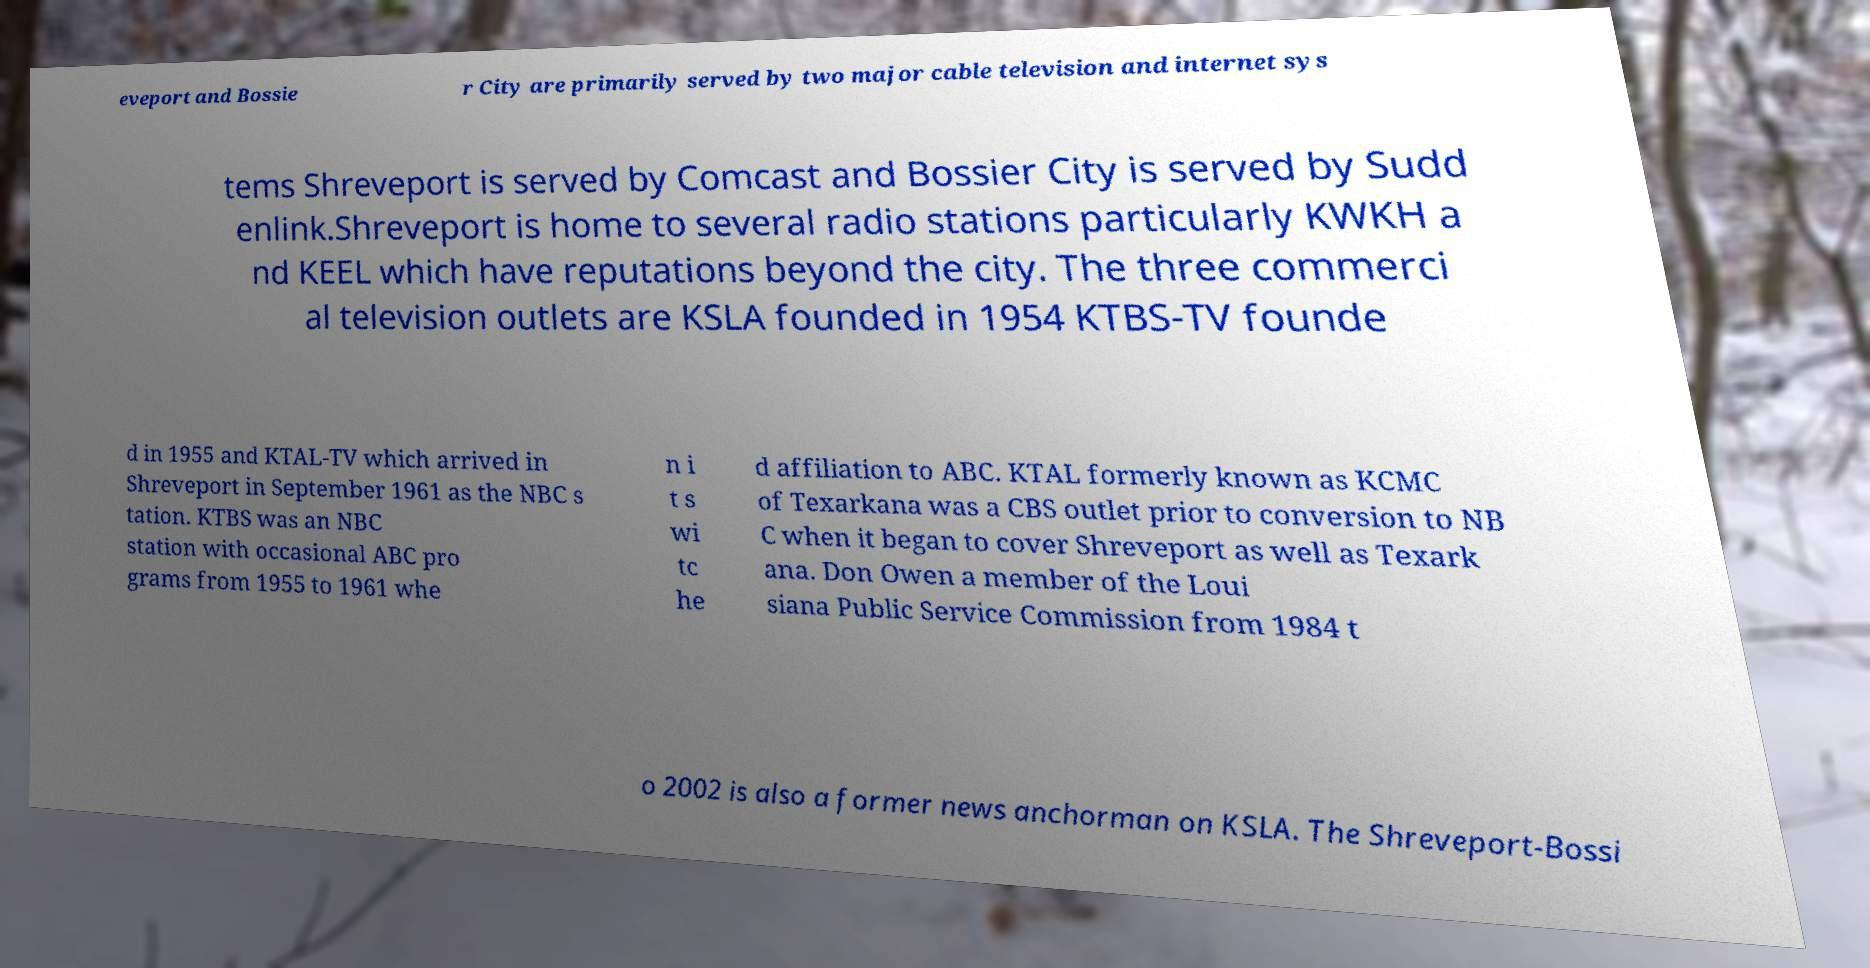What messages or text are displayed in this image? I need them in a readable, typed format. eveport and Bossie r City are primarily served by two major cable television and internet sys tems Shreveport is served by Comcast and Bossier City is served by Sudd enlink.Shreveport is home to several radio stations particularly KWKH a nd KEEL which have reputations beyond the city. The three commerci al television outlets are KSLA founded in 1954 KTBS-TV founde d in 1955 and KTAL-TV which arrived in Shreveport in September 1961 as the NBC s tation. KTBS was an NBC station with occasional ABC pro grams from 1955 to 1961 whe n i t s wi tc he d affiliation to ABC. KTAL formerly known as KCMC of Texarkana was a CBS outlet prior to conversion to NB C when it began to cover Shreveport as well as Texark ana. Don Owen a member of the Loui siana Public Service Commission from 1984 t o 2002 is also a former news anchorman on KSLA. The Shreveport-Bossi 